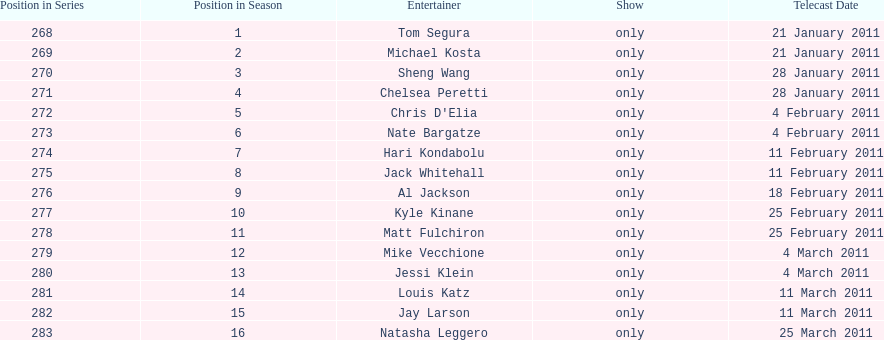Did al jackson air before or after kyle kinane? Before. 